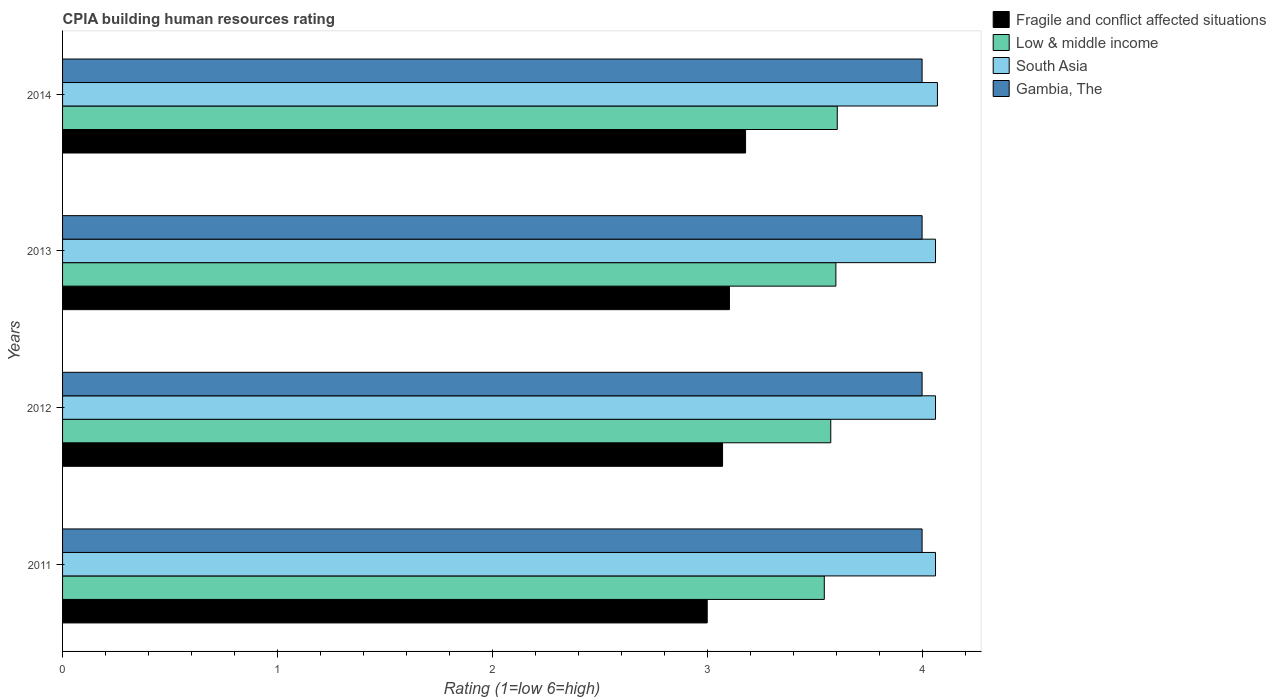How many different coloured bars are there?
Make the answer very short. 4. How many groups of bars are there?
Provide a succinct answer. 4. Are the number of bars per tick equal to the number of legend labels?
Make the answer very short. Yes. How many bars are there on the 3rd tick from the top?
Ensure brevity in your answer.  4. In how many cases, is the number of bars for a given year not equal to the number of legend labels?
Make the answer very short. 0. What is the CPIA rating in Gambia, The in 2011?
Provide a short and direct response. 4. Across all years, what is the maximum CPIA rating in South Asia?
Keep it short and to the point. 4.07. In which year was the CPIA rating in South Asia maximum?
Offer a terse response. 2014. In which year was the CPIA rating in South Asia minimum?
Keep it short and to the point. 2011. What is the total CPIA rating in South Asia in the graph?
Offer a very short reply. 16.26. What is the difference between the CPIA rating in South Asia in 2011 and that in 2013?
Keep it short and to the point. 0. What is the difference between the CPIA rating in Gambia, The in 2011 and the CPIA rating in Low & middle income in 2013?
Give a very brief answer. 0.4. What is the average CPIA rating in Gambia, The per year?
Your response must be concise. 4. In the year 2011, what is the difference between the CPIA rating in Low & middle income and CPIA rating in South Asia?
Offer a very short reply. -0.52. In how many years, is the CPIA rating in South Asia greater than 0.8 ?
Your answer should be very brief. 4. Is the difference between the CPIA rating in Low & middle income in 2011 and 2013 greater than the difference between the CPIA rating in South Asia in 2011 and 2013?
Provide a succinct answer. No. What is the difference between the highest and the second highest CPIA rating in South Asia?
Your answer should be compact. 0.01. What is the difference between the highest and the lowest CPIA rating in South Asia?
Offer a very short reply. 0.01. Is the sum of the CPIA rating in Fragile and conflict affected situations in 2013 and 2014 greater than the maximum CPIA rating in Low & middle income across all years?
Keep it short and to the point. Yes. Is it the case that in every year, the sum of the CPIA rating in Low & middle income and CPIA rating in Fragile and conflict affected situations is greater than the sum of CPIA rating in South Asia and CPIA rating in Gambia, The?
Offer a very short reply. No. What does the 1st bar from the top in 2013 represents?
Make the answer very short. Gambia, The. What does the 1st bar from the bottom in 2012 represents?
Ensure brevity in your answer.  Fragile and conflict affected situations. Is it the case that in every year, the sum of the CPIA rating in Low & middle income and CPIA rating in Gambia, The is greater than the CPIA rating in South Asia?
Make the answer very short. Yes. How many bars are there?
Provide a short and direct response. 16. Are the values on the major ticks of X-axis written in scientific E-notation?
Give a very brief answer. No. Does the graph contain grids?
Offer a very short reply. No. Where does the legend appear in the graph?
Your response must be concise. Top right. How many legend labels are there?
Ensure brevity in your answer.  4. What is the title of the graph?
Make the answer very short. CPIA building human resources rating. What is the label or title of the X-axis?
Your response must be concise. Rating (1=low 6=high). What is the label or title of the Y-axis?
Provide a short and direct response. Years. What is the Rating (1=low 6=high) of Low & middle income in 2011?
Offer a terse response. 3.54. What is the Rating (1=low 6=high) of South Asia in 2011?
Make the answer very short. 4.06. What is the Rating (1=low 6=high) of Gambia, The in 2011?
Offer a very short reply. 4. What is the Rating (1=low 6=high) of Fragile and conflict affected situations in 2012?
Your response must be concise. 3.07. What is the Rating (1=low 6=high) in Low & middle income in 2012?
Make the answer very short. 3.58. What is the Rating (1=low 6=high) of South Asia in 2012?
Your response must be concise. 4.06. What is the Rating (1=low 6=high) in Gambia, The in 2012?
Your answer should be very brief. 4. What is the Rating (1=low 6=high) of Fragile and conflict affected situations in 2013?
Offer a very short reply. 3.1. What is the Rating (1=low 6=high) of Low & middle income in 2013?
Make the answer very short. 3.6. What is the Rating (1=low 6=high) of South Asia in 2013?
Provide a short and direct response. 4.06. What is the Rating (1=low 6=high) in Fragile and conflict affected situations in 2014?
Your response must be concise. 3.18. What is the Rating (1=low 6=high) in Low & middle income in 2014?
Offer a terse response. 3.61. What is the Rating (1=low 6=high) of South Asia in 2014?
Your answer should be compact. 4.07. What is the Rating (1=low 6=high) of Gambia, The in 2014?
Your answer should be compact. 4. Across all years, what is the maximum Rating (1=low 6=high) in Fragile and conflict affected situations?
Provide a short and direct response. 3.18. Across all years, what is the maximum Rating (1=low 6=high) of Low & middle income?
Provide a short and direct response. 3.61. Across all years, what is the maximum Rating (1=low 6=high) in South Asia?
Keep it short and to the point. 4.07. Across all years, what is the minimum Rating (1=low 6=high) of Low & middle income?
Offer a very short reply. 3.54. Across all years, what is the minimum Rating (1=low 6=high) of South Asia?
Provide a short and direct response. 4.06. Across all years, what is the minimum Rating (1=low 6=high) of Gambia, The?
Provide a short and direct response. 4. What is the total Rating (1=low 6=high) of Fragile and conflict affected situations in the graph?
Ensure brevity in your answer.  12.35. What is the total Rating (1=low 6=high) in Low & middle income in the graph?
Make the answer very short. 14.32. What is the total Rating (1=low 6=high) in South Asia in the graph?
Provide a succinct answer. 16.26. What is the total Rating (1=low 6=high) of Gambia, The in the graph?
Your answer should be very brief. 16. What is the difference between the Rating (1=low 6=high) in Fragile and conflict affected situations in 2011 and that in 2012?
Offer a very short reply. -0.07. What is the difference between the Rating (1=low 6=high) of Low & middle income in 2011 and that in 2012?
Provide a succinct answer. -0.03. What is the difference between the Rating (1=low 6=high) in Gambia, The in 2011 and that in 2012?
Provide a short and direct response. 0. What is the difference between the Rating (1=low 6=high) in Fragile and conflict affected situations in 2011 and that in 2013?
Provide a short and direct response. -0.1. What is the difference between the Rating (1=low 6=high) of Low & middle income in 2011 and that in 2013?
Offer a very short reply. -0.05. What is the difference between the Rating (1=low 6=high) of South Asia in 2011 and that in 2013?
Keep it short and to the point. 0. What is the difference between the Rating (1=low 6=high) in Fragile and conflict affected situations in 2011 and that in 2014?
Make the answer very short. -0.18. What is the difference between the Rating (1=low 6=high) of Low & middle income in 2011 and that in 2014?
Your answer should be very brief. -0.06. What is the difference between the Rating (1=low 6=high) of South Asia in 2011 and that in 2014?
Offer a terse response. -0.01. What is the difference between the Rating (1=low 6=high) of Fragile and conflict affected situations in 2012 and that in 2013?
Your response must be concise. -0.03. What is the difference between the Rating (1=low 6=high) in Low & middle income in 2012 and that in 2013?
Provide a succinct answer. -0.02. What is the difference between the Rating (1=low 6=high) in South Asia in 2012 and that in 2013?
Provide a succinct answer. 0. What is the difference between the Rating (1=low 6=high) in Gambia, The in 2012 and that in 2013?
Give a very brief answer. 0. What is the difference between the Rating (1=low 6=high) in Fragile and conflict affected situations in 2012 and that in 2014?
Give a very brief answer. -0.11. What is the difference between the Rating (1=low 6=high) in Low & middle income in 2012 and that in 2014?
Provide a short and direct response. -0.03. What is the difference between the Rating (1=low 6=high) of South Asia in 2012 and that in 2014?
Provide a succinct answer. -0.01. What is the difference between the Rating (1=low 6=high) of Gambia, The in 2012 and that in 2014?
Make the answer very short. 0. What is the difference between the Rating (1=low 6=high) of Fragile and conflict affected situations in 2013 and that in 2014?
Your response must be concise. -0.08. What is the difference between the Rating (1=low 6=high) in Low & middle income in 2013 and that in 2014?
Make the answer very short. -0.01. What is the difference between the Rating (1=low 6=high) of South Asia in 2013 and that in 2014?
Keep it short and to the point. -0.01. What is the difference between the Rating (1=low 6=high) in Fragile and conflict affected situations in 2011 and the Rating (1=low 6=high) in Low & middle income in 2012?
Provide a short and direct response. -0.57. What is the difference between the Rating (1=low 6=high) in Fragile and conflict affected situations in 2011 and the Rating (1=low 6=high) in South Asia in 2012?
Ensure brevity in your answer.  -1.06. What is the difference between the Rating (1=low 6=high) in Low & middle income in 2011 and the Rating (1=low 6=high) in South Asia in 2012?
Provide a succinct answer. -0.52. What is the difference between the Rating (1=low 6=high) of Low & middle income in 2011 and the Rating (1=low 6=high) of Gambia, The in 2012?
Provide a succinct answer. -0.46. What is the difference between the Rating (1=low 6=high) of South Asia in 2011 and the Rating (1=low 6=high) of Gambia, The in 2012?
Give a very brief answer. 0.06. What is the difference between the Rating (1=low 6=high) in Fragile and conflict affected situations in 2011 and the Rating (1=low 6=high) in Low & middle income in 2013?
Your answer should be compact. -0.6. What is the difference between the Rating (1=low 6=high) in Fragile and conflict affected situations in 2011 and the Rating (1=low 6=high) in South Asia in 2013?
Provide a succinct answer. -1.06. What is the difference between the Rating (1=low 6=high) in Low & middle income in 2011 and the Rating (1=low 6=high) in South Asia in 2013?
Your response must be concise. -0.52. What is the difference between the Rating (1=low 6=high) in Low & middle income in 2011 and the Rating (1=low 6=high) in Gambia, The in 2013?
Offer a very short reply. -0.46. What is the difference between the Rating (1=low 6=high) of South Asia in 2011 and the Rating (1=low 6=high) of Gambia, The in 2013?
Offer a terse response. 0.06. What is the difference between the Rating (1=low 6=high) of Fragile and conflict affected situations in 2011 and the Rating (1=low 6=high) of Low & middle income in 2014?
Provide a short and direct response. -0.61. What is the difference between the Rating (1=low 6=high) in Fragile and conflict affected situations in 2011 and the Rating (1=low 6=high) in South Asia in 2014?
Offer a very short reply. -1.07. What is the difference between the Rating (1=low 6=high) of Fragile and conflict affected situations in 2011 and the Rating (1=low 6=high) of Gambia, The in 2014?
Your answer should be compact. -1. What is the difference between the Rating (1=low 6=high) of Low & middle income in 2011 and the Rating (1=low 6=high) of South Asia in 2014?
Provide a succinct answer. -0.53. What is the difference between the Rating (1=low 6=high) in Low & middle income in 2011 and the Rating (1=low 6=high) in Gambia, The in 2014?
Provide a succinct answer. -0.46. What is the difference between the Rating (1=low 6=high) in South Asia in 2011 and the Rating (1=low 6=high) in Gambia, The in 2014?
Provide a succinct answer. 0.06. What is the difference between the Rating (1=low 6=high) of Fragile and conflict affected situations in 2012 and the Rating (1=low 6=high) of Low & middle income in 2013?
Your answer should be compact. -0.53. What is the difference between the Rating (1=low 6=high) in Fragile and conflict affected situations in 2012 and the Rating (1=low 6=high) in South Asia in 2013?
Ensure brevity in your answer.  -0.99. What is the difference between the Rating (1=low 6=high) of Fragile and conflict affected situations in 2012 and the Rating (1=low 6=high) of Gambia, The in 2013?
Provide a short and direct response. -0.93. What is the difference between the Rating (1=low 6=high) of Low & middle income in 2012 and the Rating (1=low 6=high) of South Asia in 2013?
Ensure brevity in your answer.  -0.49. What is the difference between the Rating (1=low 6=high) in Low & middle income in 2012 and the Rating (1=low 6=high) in Gambia, The in 2013?
Offer a terse response. -0.42. What is the difference between the Rating (1=low 6=high) of South Asia in 2012 and the Rating (1=low 6=high) of Gambia, The in 2013?
Your answer should be very brief. 0.06. What is the difference between the Rating (1=low 6=high) in Fragile and conflict affected situations in 2012 and the Rating (1=low 6=high) in Low & middle income in 2014?
Provide a succinct answer. -0.53. What is the difference between the Rating (1=low 6=high) of Fragile and conflict affected situations in 2012 and the Rating (1=low 6=high) of South Asia in 2014?
Your answer should be very brief. -1. What is the difference between the Rating (1=low 6=high) in Fragile and conflict affected situations in 2012 and the Rating (1=low 6=high) in Gambia, The in 2014?
Make the answer very short. -0.93. What is the difference between the Rating (1=low 6=high) of Low & middle income in 2012 and the Rating (1=low 6=high) of South Asia in 2014?
Offer a very short reply. -0.5. What is the difference between the Rating (1=low 6=high) in Low & middle income in 2012 and the Rating (1=low 6=high) in Gambia, The in 2014?
Provide a succinct answer. -0.42. What is the difference between the Rating (1=low 6=high) in South Asia in 2012 and the Rating (1=low 6=high) in Gambia, The in 2014?
Provide a succinct answer. 0.06. What is the difference between the Rating (1=low 6=high) in Fragile and conflict affected situations in 2013 and the Rating (1=low 6=high) in Low & middle income in 2014?
Offer a very short reply. -0.5. What is the difference between the Rating (1=low 6=high) in Fragile and conflict affected situations in 2013 and the Rating (1=low 6=high) in South Asia in 2014?
Offer a very short reply. -0.97. What is the difference between the Rating (1=low 6=high) of Fragile and conflict affected situations in 2013 and the Rating (1=low 6=high) of Gambia, The in 2014?
Make the answer very short. -0.9. What is the difference between the Rating (1=low 6=high) of Low & middle income in 2013 and the Rating (1=low 6=high) of South Asia in 2014?
Ensure brevity in your answer.  -0.47. What is the difference between the Rating (1=low 6=high) of Low & middle income in 2013 and the Rating (1=low 6=high) of Gambia, The in 2014?
Provide a short and direct response. -0.4. What is the difference between the Rating (1=low 6=high) of South Asia in 2013 and the Rating (1=low 6=high) of Gambia, The in 2014?
Ensure brevity in your answer.  0.06. What is the average Rating (1=low 6=high) of Fragile and conflict affected situations per year?
Provide a succinct answer. 3.09. What is the average Rating (1=low 6=high) of Low & middle income per year?
Offer a very short reply. 3.58. What is the average Rating (1=low 6=high) in South Asia per year?
Give a very brief answer. 4.06. In the year 2011, what is the difference between the Rating (1=low 6=high) of Fragile and conflict affected situations and Rating (1=low 6=high) of Low & middle income?
Give a very brief answer. -0.54. In the year 2011, what is the difference between the Rating (1=low 6=high) of Fragile and conflict affected situations and Rating (1=low 6=high) of South Asia?
Keep it short and to the point. -1.06. In the year 2011, what is the difference between the Rating (1=low 6=high) of Low & middle income and Rating (1=low 6=high) of South Asia?
Offer a very short reply. -0.52. In the year 2011, what is the difference between the Rating (1=low 6=high) of Low & middle income and Rating (1=low 6=high) of Gambia, The?
Ensure brevity in your answer.  -0.46. In the year 2011, what is the difference between the Rating (1=low 6=high) of South Asia and Rating (1=low 6=high) of Gambia, The?
Keep it short and to the point. 0.06. In the year 2012, what is the difference between the Rating (1=low 6=high) of Fragile and conflict affected situations and Rating (1=low 6=high) of Low & middle income?
Keep it short and to the point. -0.5. In the year 2012, what is the difference between the Rating (1=low 6=high) of Fragile and conflict affected situations and Rating (1=low 6=high) of South Asia?
Make the answer very short. -0.99. In the year 2012, what is the difference between the Rating (1=low 6=high) of Fragile and conflict affected situations and Rating (1=low 6=high) of Gambia, The?
Keep it short and to the point. -0.93. In the year 2012, what is the difference between the Rating (1=low 6=high) of Low & middle income and Rating (1=low 6=high) of South Asia?
Your answer should be very brief. -0.49. In the year 2012, what is the difference between the Rating (1=low 6=high) of Low & middle income and Rating (1=low 6=high) of Gambia, The?
Give a very brief answer. -0.42. In the year 2012, what is the difference between the Rating (1=low 6=high) in South Asia and Rating (1=low 6=high) in Gambia, The?
Your answer should be very brief. 0.06. In the year 2013, what is the difference between the Rating (1=low 6=high) of Fragile and conflict affected situations and Rating (1=low 6=high) of Low & middle income?
Offer a terse response. -0.5. In the year 2013, what is the difference between the Rating (1=low 6=high) of Fragile and conflict affected situations and Rating (1=low 6=high) of South Asia?
Ensure brevity in your answer.  -0.96. In the year 2013, what is the difference between the Rating (1=low 6=high) in Fragile and conflict affected situations and Rating (1=low 6=high) in Gambia, The?
Your response must be concise. -0.9. In the year 2013, what is the difference between the Rating (1=low 6=high) in Low & middle income and Rating (1=low 6=high) in South Asia?
Your answer should be compact. -0.46. In the year 2013, what is the difference between the Rating (1=low 6=high) in Low & middle income and Rating (1=low 6=high) in Gambia, The?
Your response must be concise. -0.4. In the year 2013, what is the difference between the Rating (1=low 6=high) of South Asia and Rating (1=low 6=high) of Gambia, The?
Make the answer very short. 0.06. In the year 2014, what is the difference between the Rating (1=low 6=high) in Fragile and conflict affected situations and Rating (1=low 6=high) in Low & middle income?
Give a very brief answer. -0.43. In the year 2014, what is the difference between the Rating (1=low 6=high) in Fragile and conflict affected situations and Rating (1=low 6=high) in South Asia?
Your answer should be compact. -0.89. In the year 2014, what is the difference between the Rating (1=low 6=high) in Fragile and conflict affected situations and Rating (1=low 6=high) in Gambia, The?
Your answer should be compact. -0.82. In the year 2014, what is the difference between the Rating (1=low 6=high) of Low & middle income and Rating (1=low 6=high) of South Asia?
Make the answer very short. -0.47. In the year 2014, what is the difference between the Rating (1=low 6=high) in Low & middle income and Rating (1=low 6=high) in Gambia, The?
Provide a succinct answer. -0.39. In the year 2014, what is the difference between the Rating (1=low 6=high) in South Asia and Rating (1=low 6=high) in Gambia, The?
Offer a very short reply. 0.07. What is the ratio of the Rating (1=low 6=high) of Fragile and conflict affected situations in 2011 to that in 2012?
Provide a short and direct response. 0.98. What is the ratio of the Rating (1=low 6=high) in Low & middle income in 2011 to that in 2012?
Your answer should be very brief. 0.99. What is the ratio of the Rating (1=low 6=high) of Fragile and conflict affected situations in 2011 to that in 2013?
Your answer should be compact. 0.97. What is the ratio of the Rating (1=low 6=high) in Gambia, The in 2011 to that in 2013?
Your answer should be compact. 1. What is the ratio of the Rating (1=low 6=high) in Fragile and conflict affected situations in 2011 to that in 2014?
Keep it short and to the point. 0.94. What is the ratio of the Rating (1=low 6=high) in Low & middle income in 2011 to that in 2014?
Offer a terse response. 0.98. What is the ratio of the Rating (1=low 6=high) of South Asia in 2011 to that in 2014?
Keep it short and to the point. 1. What is the ratio of the Rating (1=low 6=high) of South Asia in 2012 to that in 2013?
Give a very brief answer. 1. What is the ratio of the Rating (1=low 6=high) in Fragile and conflict affected situations in 2012 to that in 2014?
Provide a succinct answer. 0.97. What is the ratio of the Rating (1=low 6=high) in Low & middle income in 2012 to that in 2014?
Your answer should be compact. 0.99. What is the ratio of the Rating (1=low 6=high) of South Asia in 2012 to that in 2014?
Offer a very short reply. 1. What is the ratio of the Rating (1=low 6=high) of Fragile and conflict affected situations in 2013 to that in 2014?
Your response must be concise. 0.98. What is the difference between the highest and the second highest Rating (1=low 6=high) of Fragile and conflict affected situations?
Your response must be concise. 0.08. What is the difference between the highest and the second highest Rating (1=low 6=high) of Low & middle income?
Your answer should be very brief. 0.01. What is the difference between the highest and the second highest Rating (1=low 6=high) in South Asia?
Give a very brief answer. 0.01. What is the difference between the highest and the lowest Rating (1=low 6=high) in Fragile and conflict affected situations?
Ensure brevity in your answer.  0.18. What is the difference between the highest and the lowest Rating (1=low 6=high) in Low & middle income?
Make the answer very short. 0.06. What is the difference between the highest and the lowest Rating (1=low 6=high) of South Asia?
Your response must be concise. 0.01. What is the difference between the highest and the lowest Rating (1=low 6=high) of Gambia, The?
Provide a short and direct response. 0. 